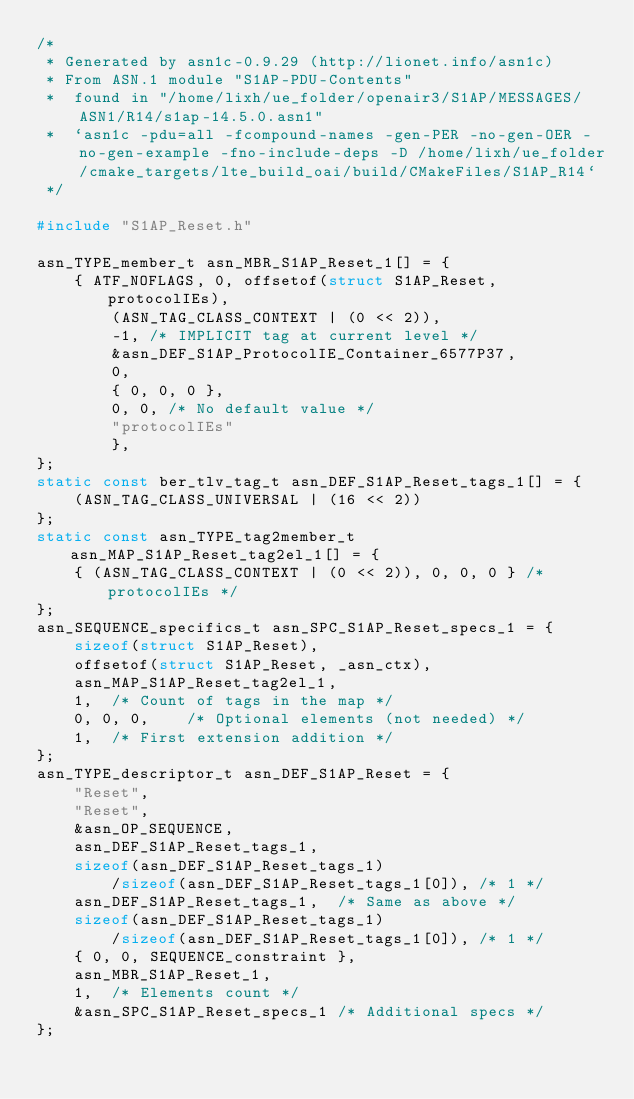Convert code to text. <code><loc_0><loc_0><loc_500><loc_500><_C_>/*
 * Generated by asn1c-0.9.29 (http://lionet.info/asn1c)
 * From ASN.1 module "S1AP-PDU-Contents"
 * 	found in "/home/lixh/ue_folder/openair3/S1AP/MESSAGES/ASN1/R14/s1ap-14.5.0.asn1"
 * 	`asn1c -pdu=all -fcompound-names -gen-PER -no-gen-OER -no-gen-example -fno-include-deps -D /home/lixh/ue_folder/cmake_targets/lte_build_oai/build/CMakeFiles/S1AP_R14`
 */

#include "S1AP_Reset.h"

asn_TYPE_member_t asn_MBR_S1AP_Reset_1[] = {
	{ ATF_NOFLAGS, 0, offsetof(struct S1AP_Reset, protocolIEs),
		(ASN_TAG_CLASS_CONTEXT | (0 << 2)),
		-1,	/* IMPLICIT tag at current level */
		&asn_DEF_S1AP_ProtocolIE_Container_6577P37,
		0,
		{ 0, 0, 0 },
		0, 0, /* No default value */
		"protocolIEs"
		},
};
static const ber_tlv_tag_t asn_DEF_S1AP_Reset_tags_1[] = {
	(ASN_TAG_CLASS_UNIVERSAL | (16 << 2))
};
static const asn_TYPE_tag2member_t asn_MAP_S1AP_Reset_tag2el_1[] = {
    { (ASN_TAG_CLASS_CONTEXT | (0 << 2)), 0, 0, 0 } /* protocolIEs */
};
asn_SEQUENCE_specifics_t asn_SPC_S1AP_Reset_specs_1 = {
	sizeof(struct S1AP_Reset),
	offsetof(struct S1AP_Reset, _asn_ctx),
	asn_MAP_S1AP_Reset_tag2el_1,
	1,	/* Count of tags in the map */
	0, 0, 0,	/* Optional elements (not needed) */
	1,	/* First extension addition */
};
asn_TYPE_descriptor_t asn_DEF_S1AP_Reset = {
	"Reset",
	"Reset",
	&asn_OP_SEQUENCE,
	asn_DEF_S1AP_Reset_tags_1,
	sizeof(asn_DEF_S1AP_Reset_tags_1)
		/sizeof(asn_DEF_S1AP_Reset_tags_1[0]), /* 1 */
	asn_DEF_S1AP_Reset_tags_1,	/* Same as above */
	sizeof(asn_DEF_S1AP_Reset_tags_1)
		/sizeof(asn_DEF_S1AP_Reset_tags_1[0]), /* 1 */
	{ 0, 0, SEQUENCE_constraint },
	asn_MBR_S1AP_Reset_1,
	1,	/* Elements count */
	&asn_SPC_S1AP_Reset_specs_1	/* Additional specs */
};

</code> 